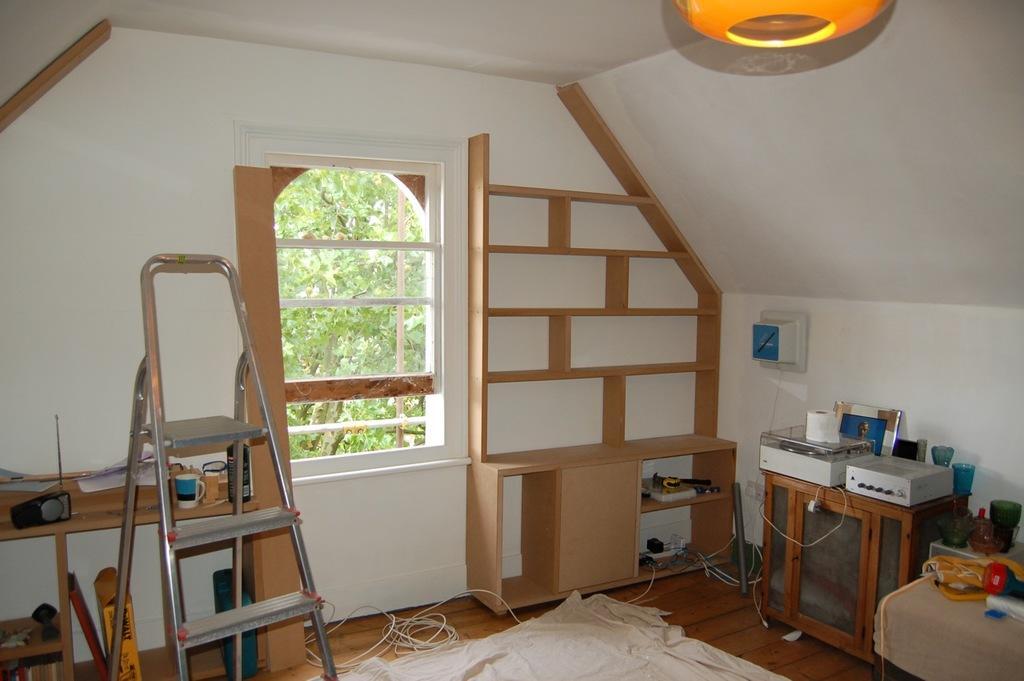Please provide a concise description of this image. This picture is clicked inside the room. Here, we see a wooden cupboard. Beside that, we see a table on which two boxes, tissue paper and photo frame and two glasses are placed. Beside that, we see a bed. On the left corner of the picture, we see ladder. Beside that, we see a window from which we see trees. On the bottom of the picture, we see white carpet on the floor. 